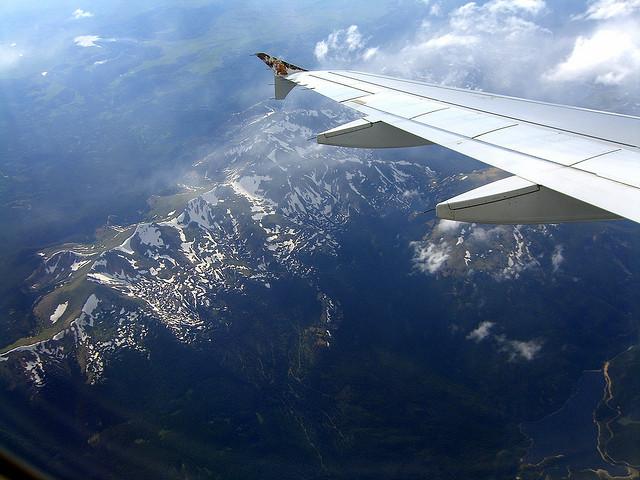Would you use the item partially pictured to travel somewhere?
Be succinct. Yes. Can you see clouds?
Short answer required. Yes. Is there an airplane wing in the picture?
Answer briefly. Yes. Is the sun on the right?
Concise answer only. Yes. 